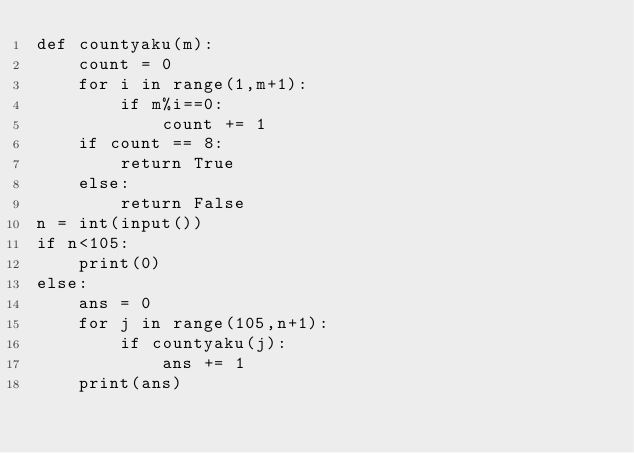Convert code to text. <code><loc_0><loc_0><loc_500><loc_500><_Python_>def countyaku(m):
    count = 0
    for i in range(1,m+1):
        if m%i==0:
            count += 1
    if count == 8:
        return True
    else:
        return False
n = int(input())
if n<105:
    print(0)
else:
    ans = 0
    for j in range(105,n+1):
        if countyaku(j):
            ans += 1
    print(ans)

</code> 